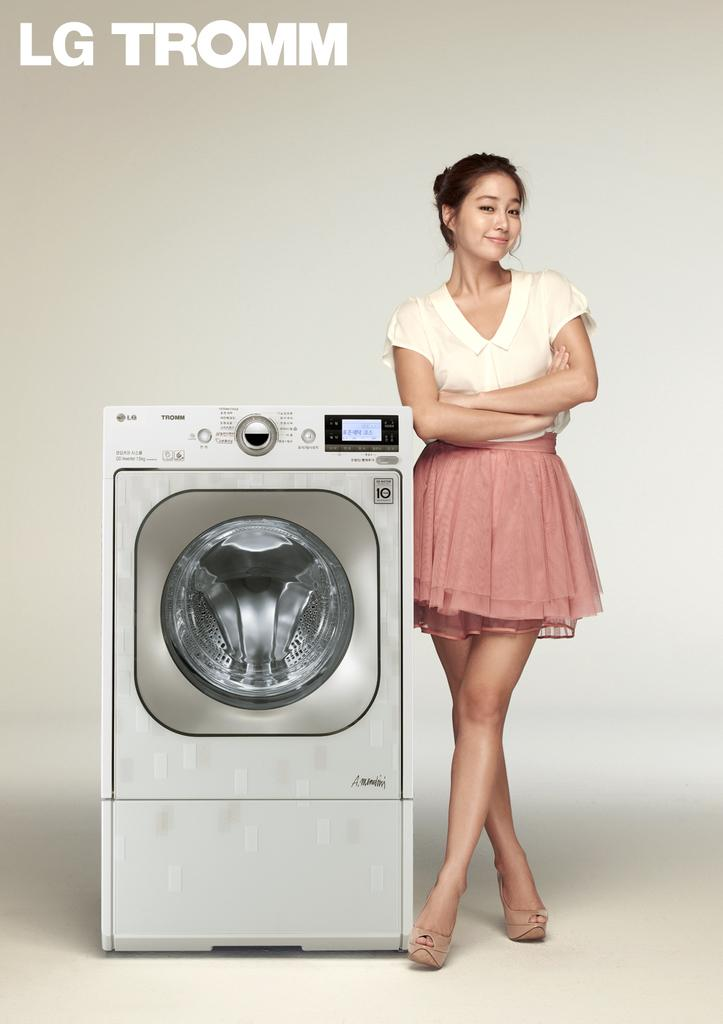Who is present in the image? There is a woman in the image. What is the woman doing in the image? The woman is standing and smiling. What appliance can be seen in the image? There is a washing machine in the image. Is there any text visible in the image? Yes, there is some text in the top left corner of the image. What type of waste can be seen in the image? There is no waste visible in the image. 